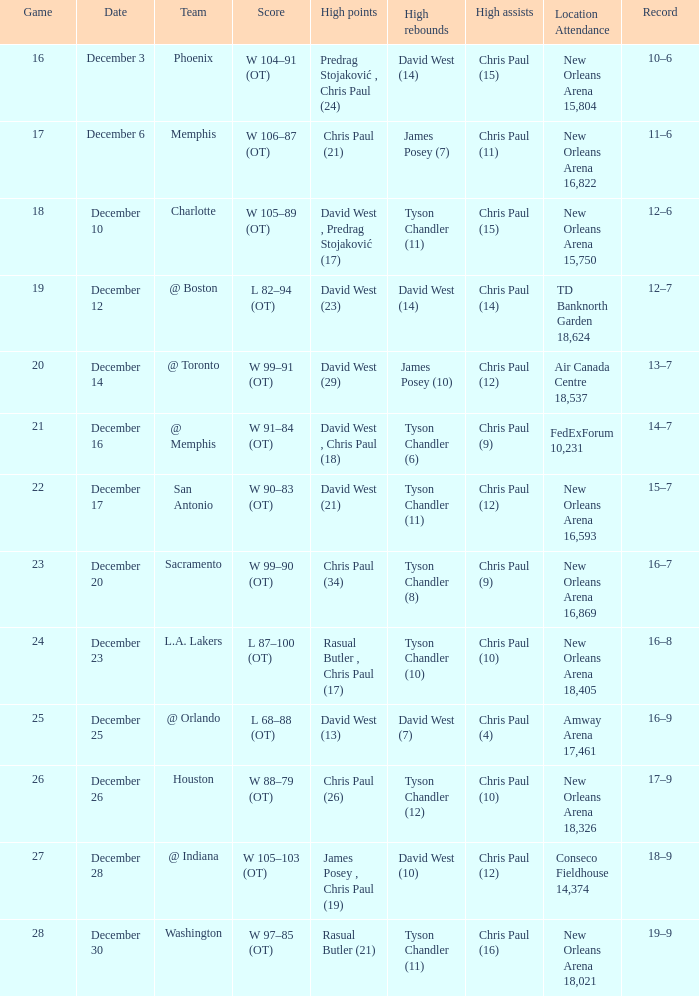What is the average Game, when Date is "December 23"? 24.0. 